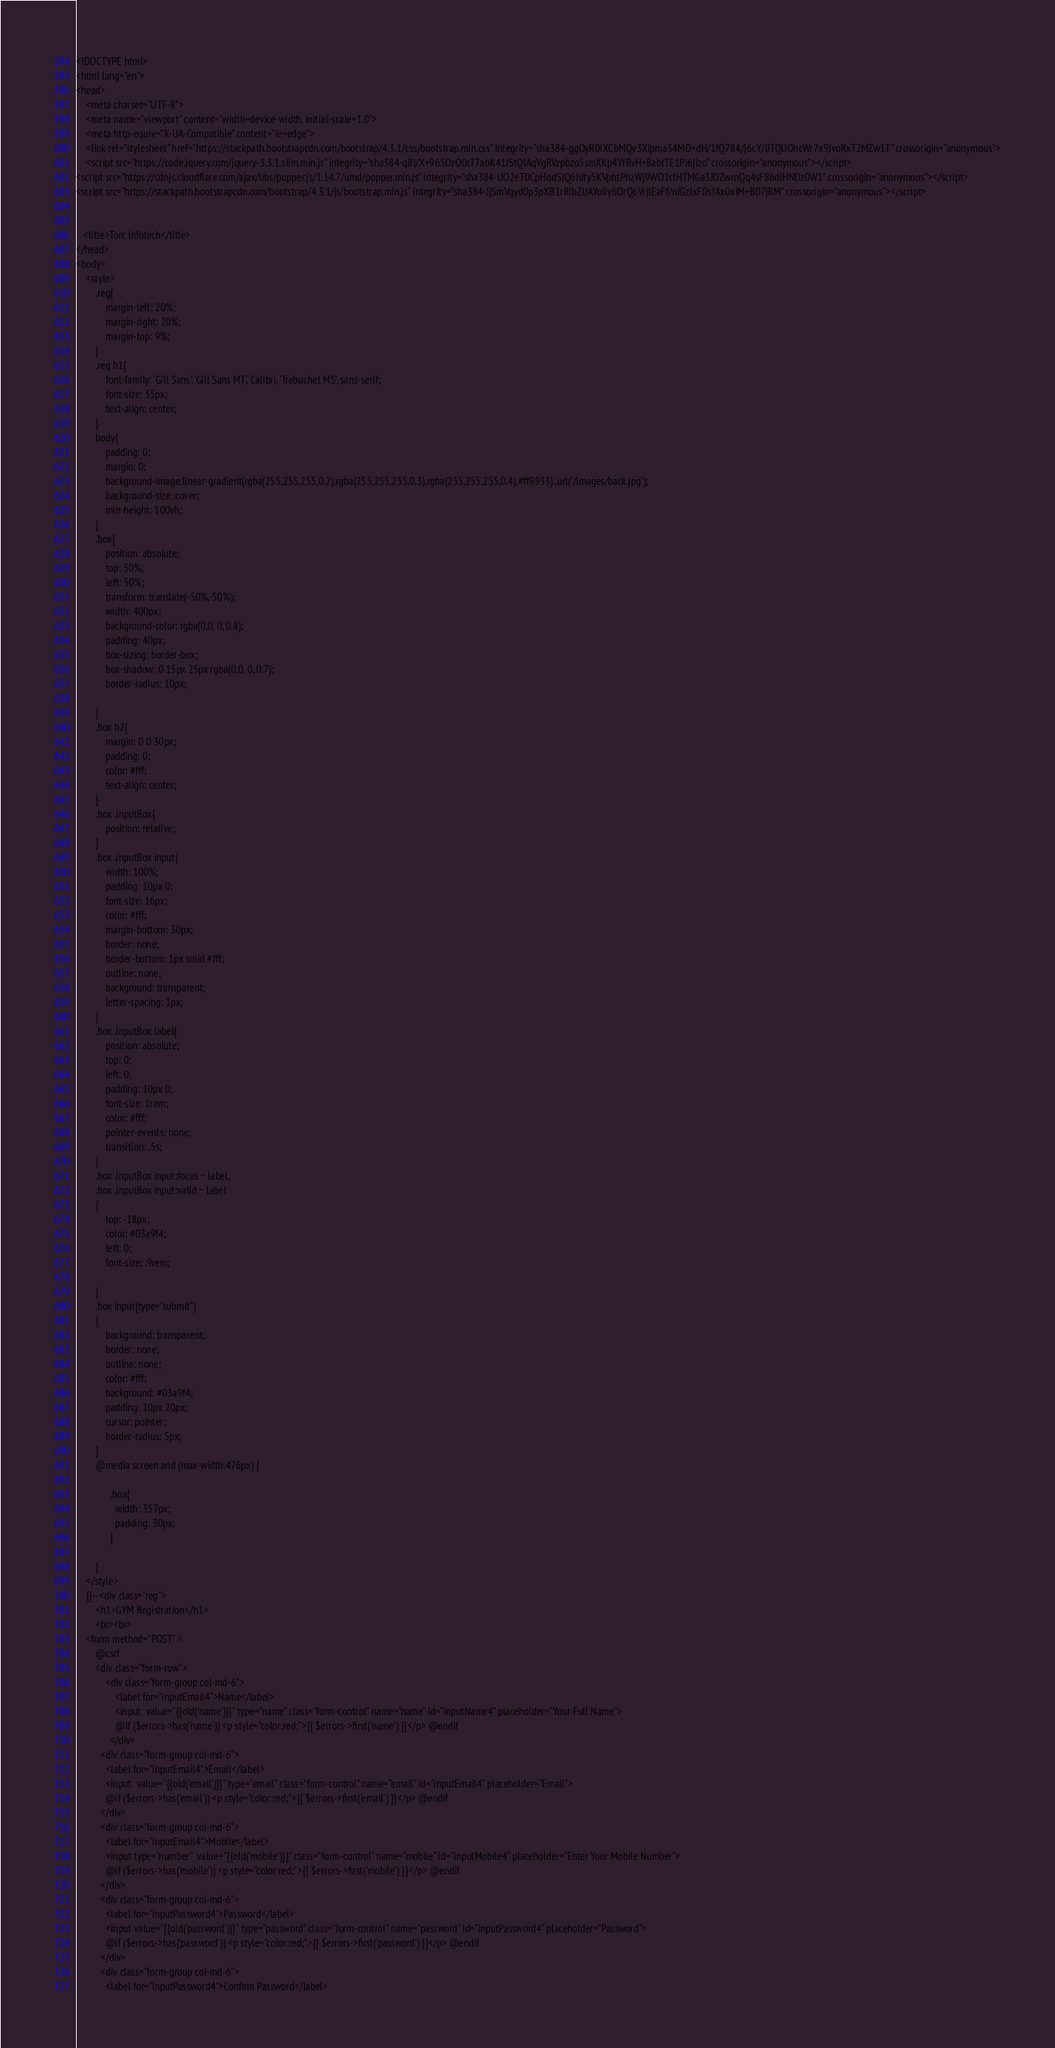Convert code to text. <code><loc_0><loc_0><loc_500><loc_500><_PHP_><!DOCTYPE html>
<html lang="en">
<head>
    <meta charset="UTF-8">
    <meta name="viewport" content="width=device-width, initial-scale=1.0">
    <meta http-equiv="X-UA-Compatible" content="ie=edge">
    <link rel="stylesheet" href="https://stackpath.bootstrapcdn.com/bootstrap/4.3.1/css/bootstrap.min.css" integrity="sha384-ggOyR0iXCbMQv3Xipma34MD+dH/1fQ784/j6cY/iJTQUOhcWr7x9JvoRxT2MZw1T" crossorigin="anonymous">
    <script src="https://code.jquery.com/jquery-3.3.1.slim.min.js" integrity="sha384-q8i/X+965DzO0rT7abK41JStQIAqVgRVzpbzo5smXKp4YfRvH+8abtTE1Pi6jizo" crossorigin="anonymous"></script>
<script src="https://cdnjs.cloudflare.com/ajax/libs/popper.js/1.14.7/umd/popper.min.js" integrity="sha384-UO2eT0CpHqdSJQ6hJty5KVphtPhzWj9WO1clHTMGa3JDZwrnQq4sF86dIHNDz0W1" crossorigin="anonymous"></script>
<script src="https://stackpath.bootstrapcdn.com/bootstrap/4.3.1/js/bootstrap.min.js" integrity="sha384-JjSmVgyd0p3pXB1rRibZUAYoIIy6OrQ6VrjIEaFf/nJGzIxFDsf4x0xIM+B07jRM" crossorigin="anonymous"></script>


   <title>Torc Infotech</title>
</head>
<body>
    <style>
        .reg{
            margin-left: 20%;
            margin-right: 20%;
            margin-top: 9%;
        }
        .reg h1{
            font-family: 'Gill Sans', 'Gill Sans MT', Calibri, 'Trebuchet MS', sans-serif;
            font-size: 35px;
            text-align: center;
        }
        body{
            padding: 0;
            margin: 0;
            background-image:linear-gradient(rgba(255,255,255,0.2),rgba(255,255,255,0.3),rgba(255,255,255,0.4),#ff9933) ,url('/images/back.jpg');
            background-size: cover;
            min-height: 100vh;
        }
        .box{
            position: absolute;
            top: 50%;
            left: 50%;
            transform: translate(-50%,-50%);
            width: 400px;
            background-color: rgba(0,0, 0, 0.8);
            padding: 40px;
            box-sizing: border-box;
            box-shadow: 0 15px 25px rgba(0,0, 0, 0.7);
            border-radius: 10px;

        }
        .box h2{
            margin: 0 0 30px;
            padding: 0;
            color: #fff;
            text-align: center;
        }
        .box .inputBox{
            position: relative;
        }
        .box .inputBox input{
            width: 100%;
            padding: 10px 0;
            font-size: 16px;
            color: #fff;
            margin-bottom: 30px;
            border: none;
            border-bottom: 1px solid #fff;
            outline: none;
            background: transparent;
            letter-spacing: 1px;
        }
        .box .inputBox label{
            position: absolute;
            top: 0;
            left: 0;
            padding: 10px 0;
            font-size: 1rem;
            color: #fff;
            pointer-events: none;
            transition: .5s;
        }
        .box .inputBox input:focus ~ label,
        .box .inputBox input:valid ~ label
        {
            top: -18px;
            color: #03a9f4;
            left: 0;
            font-size: .9rem;

        }
        .box input[type="submit"]
        {
            background: transparent;
            border: none;
            outline: none;
            color: #fff;
            background: #03a9f4;
            padding: 10px 20px;
            cursor: pointer;
            border-radius: 5px;
        }
        @media screen and (max-width:476px) {

              .box{
                width: 357px;
                padding: 30px;
              }

        }
    </style>
    {{--<div class="reg">
        <h1>GYM Registration</h1>
        <br><br>
    <form method="POST" >
        @csrf
        <div class="form-row">
            <div class="form-group col-md-6">
                <label for="inputEmail4">Name</label>
                <input  value="{{old('name')}}" type="name" class="form-control" name="name" id="inputName4" placeholder="Your Full Name">
                @if ($errors->has('name')) <p style="color:red;">{{ $errors->first('name') }}</p> @endif
              </div>
          <div class="form-group col-md-6">
            <label for="inputEmail4">Email</label>
            <input  value="{{old('email')}}" type="email" class="form-control" name="email" id="inputEmail4" placeholder="Email">
            @if ($errors->has('email')) <p style="color:red;">{{ $errors->first('email') }}</p> @endif
          </div>
          <div class="form-group col-md-6">
            <label for="inputEmail4">Mobile</label>
            <input type="number"  value="{{old('mobile')}}" class="form-control" name="mobile" id="inputMobile4" placeholder="Enter Your Mobile Number">
            @if ($errors->has('mobile')) <p style="color:red;">{{ $errors->first('mobile') }}</p> @endif
          </div>
          <div class="form-group col-md-6">
            <label for="inputPassword4">Password</label>
            <input value="{{old('password')}}" type="password" class="form-control" name="password" id="inputPassword4" placeholder="Password">
            @if ($errors->has('password')) <p style="color:red;">{{ $errors->first('password') }}</p> @endif
          </div>
          <div class="form-group col-md-6">
            <label for="inputPassword4">Confirm Password</label></code> 